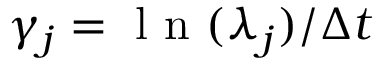Convert formula to latex. <formula><loc_0><loc_0><loc_500><loc_500>\gamma _ { j } = { l n ( \lambda _ { j } ) } / { \Delta t }</formula> 